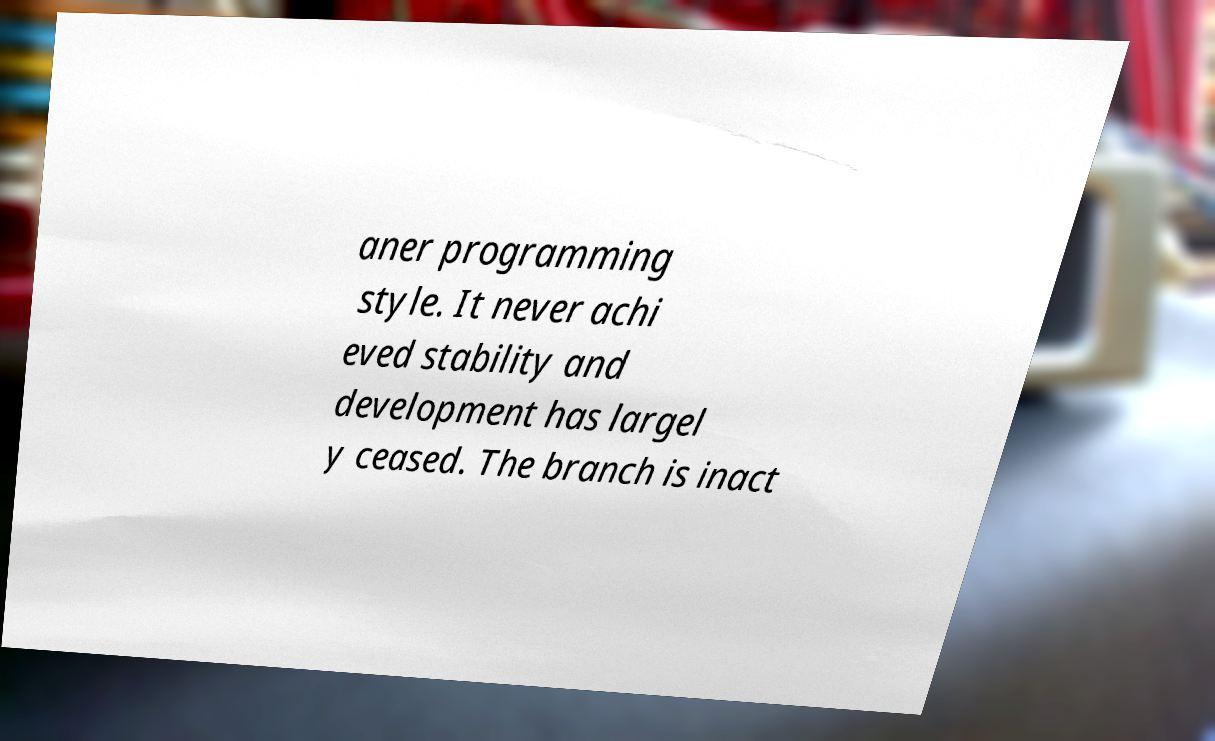Please identify and transcribe the text found in this image. aner programming style. It never achi eved stability and development has largel y ceased. The branch is inact 